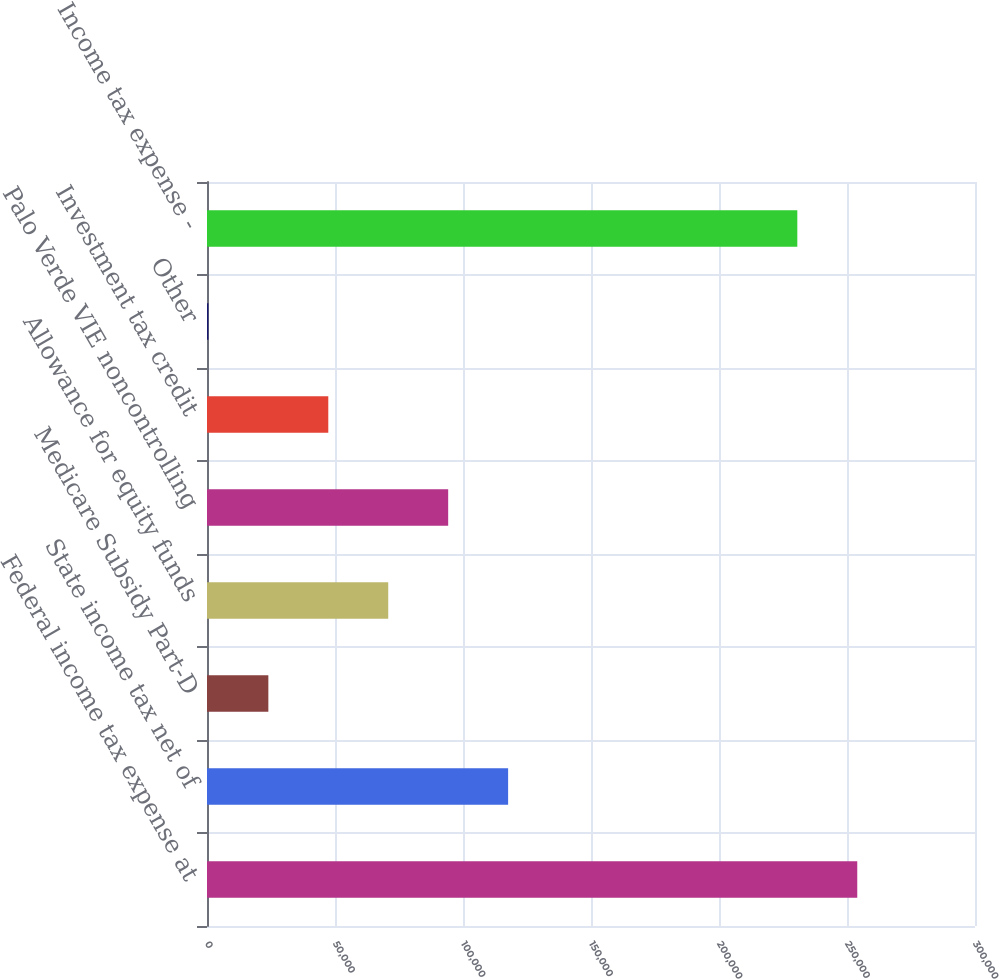Convert chart. <chart><loc_0><loc_0><loc_500><loc_500><bar_chart><fcel>Federal income tax expense at<fcel>State income tax net of<fcel>Medicare Subsidy Part-D<fcel>Allowance for equity funds<fcel>Palo Verde VIE noncontrolling<fcel>Investment tax credit<fcel>Other<fcel>Income tax expense -<nl><fcel>254005<fcel>117623<fcel>23965.4<fcel>70794.2<fcel>94208.6<fcel>47379.8<fcel>551<fcel>230591<nl></chart> 